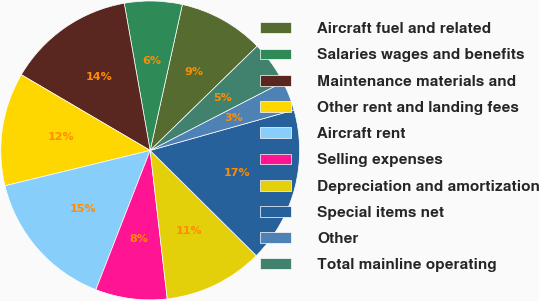Convert chart. <chart><loc_0><loc_0><loc_500><loc_500><pie_chart><fcel>Aircraft fuel and related<fcel>Salaries wages and benefits<fcel>Maintenance materials and<fcel>Other rent and landing fees<fcel>Aircraft rent<fcel>Selling expenses<fcel>Depreciation and amortization<fcel>Special items net<fcel>Other<fcel>Total mainline operating<nl><fcel>9.25%<fcel>6.23%<fcel>13.77%<fcel>12.26%<fcel>15.28%<fcel>7.74%<fcel>10.75%<fcel>16.79%<fcel>3.21%<fcel>4.72%<nl></chart> 